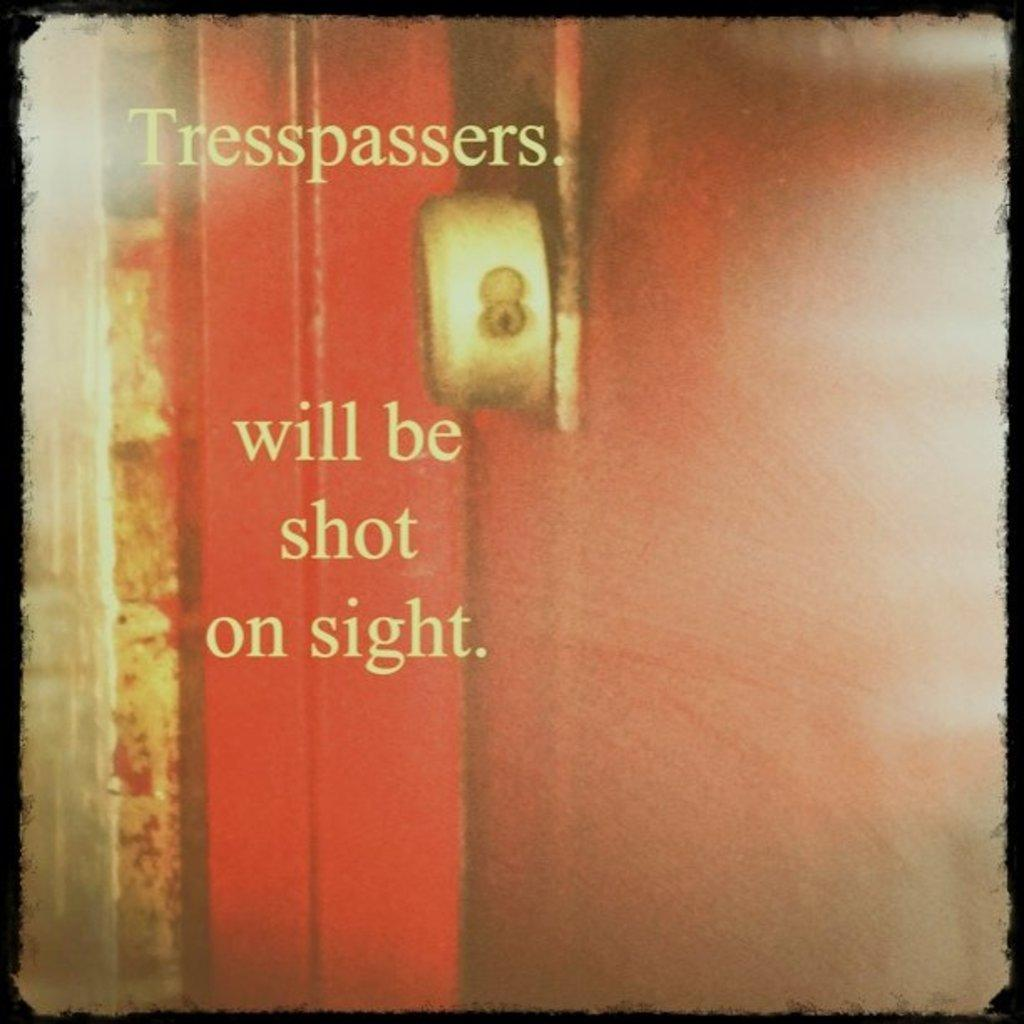<image>
Present a compact description of the photo's key features. Tresspassers will be shot on sight at a door 